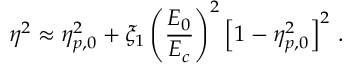Convert formula to latex. <formula><loc_0><loc_0><loc_500><loc_500>\eta ^ { 2 } \approx \eta _ { p , 0 } ^ { 2 } + \xi _ { 1 } \left ( \frac { E _ { 0 } } { E _ { c } } \right ) ^ { 2 } \left [ 1 - \eta _ { p , 0 } ^ { 2 } \right ] ^ { 2 } \, .</formula> 